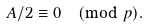<formula> <loc_0><loc_0><loc_500><loc_500>A / 2 \equiv 0 \pmod { p } .</formula> 